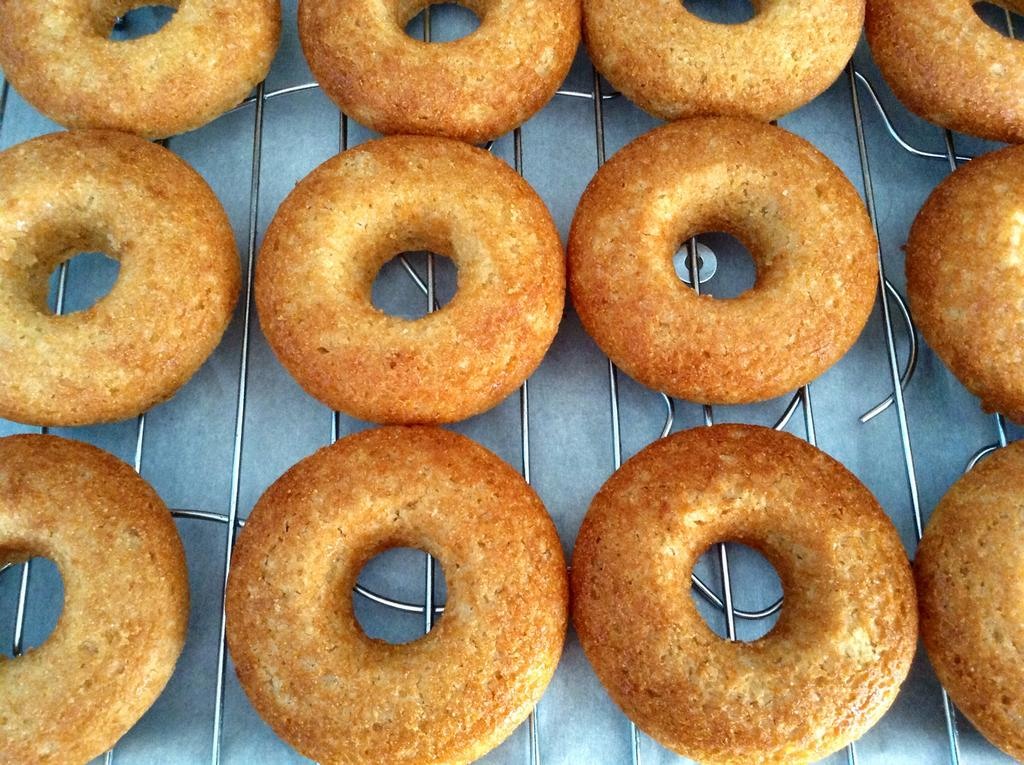What type of food is being prepared on the grill in the image? There are donuts on a grill in the image. What is located at the bottom of the grill? There is a paper at the bottom of the grill in the image. What type of ornament is hanging from the ceiling in the image? There is no ornament hanging from the ceiling in the image; the image only shows donuts on a grill and a paper at the bottom of the grill. 